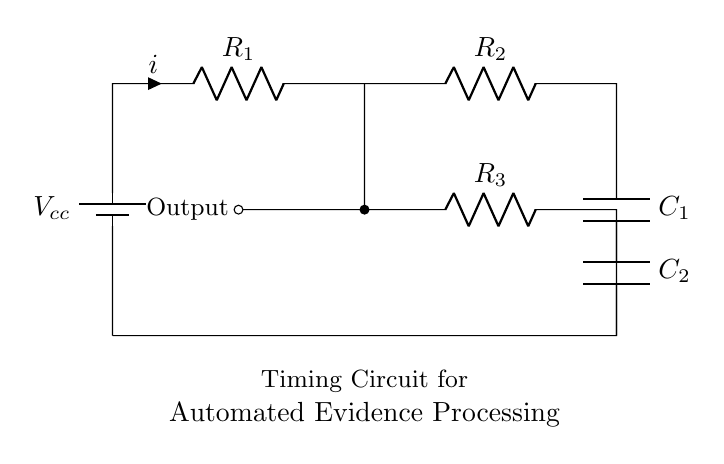What is the total number of resistors in the circuit? The circuit diagram shows three resistors: R1, R2, and R3. Each of these is labeled clearly, confirming their presence.
Answer: 3 What are the values of the capacitors used in the circuit? The circuit shows two capacitors, C1 and C2, but does not specify their values in the diagram. Therefore, the value is not provided directly in the visual information.
Answer: Not provided What is the purpose of R3 in this circuit? R3 acts as a pull-up resistor towards the output, helping to maintain a stable voltage level for the timing function. It connects the output node to the higher voltage level when needed and thus helps control the timing mechanism effectively.
Answer: Pull-up resistor What is the output node's connection type? The output node is indicated with a short dash-o, which signifies it as a 'passive output' connection that signifies it can drive a load or connect to another circuit but does not supply power actively.
Answer: Passive output What effect does increasing R1 have on the timing circuit? Increasing R1 results in a longer time constant, which slows down the charging time of capacitor C1, thus causing a longer delay in the output signal. This is based on the RC time constant formula, which incorporates resistance (R1) and capacitance (C1).
Answer: Longer delay What is the function of capacitor C2 in this circuit? C2 functions in conjunction with R3 to smooth output signals and filter any noise, enhancing the reliability of the timing output. Capacitors in timing circuits are often employed for stabilization and signal quality improvement.
Answer: Smoothing and filtering 